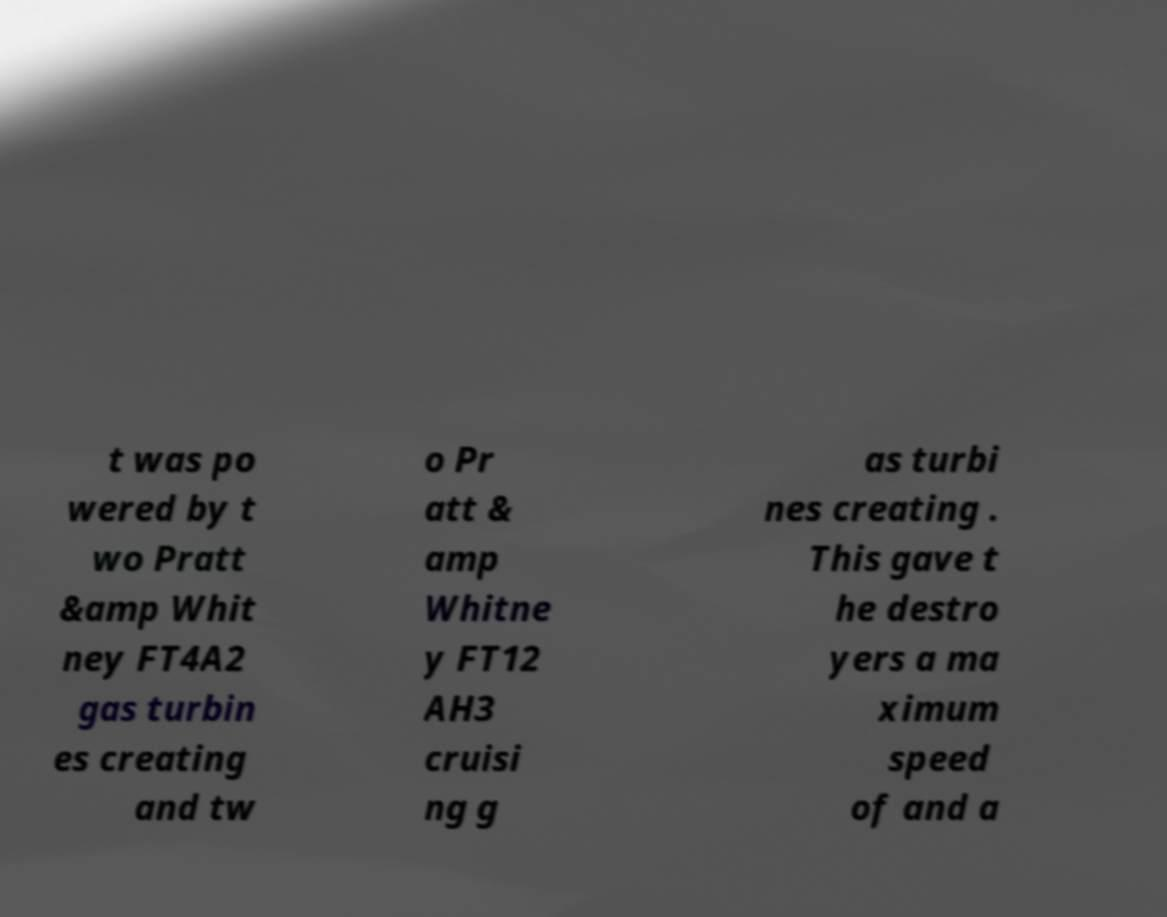Can you read and provide the text displayed in the image?This photo seems to have some interesting text. Can you extract and type it out for me? t was po wered by t wo Pratt &amp Whit ney FT4A2 gas turbin es creating and tw o Pr att & amp Whitne y FT12 AH3 cruisi ng g as turbi nes creating . This gave t he destro yers a ma ximum speed of and a 